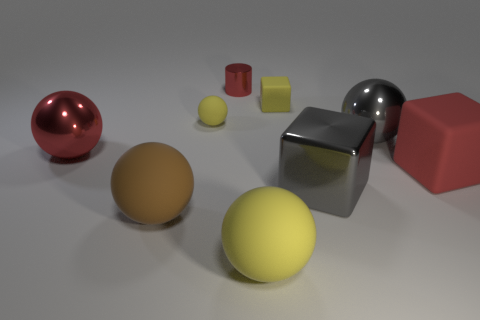Add 1 large gray cubes. How many objects exist? 10 Subtract all yellow balls. How many balls are left? 3 Subtract all large yellow spheres. How many spheres are left? 4 Subtract 1 red spheres. How many objects are left? 8 Subtract all cubes. How many objects are left? 6 Subtract 2 spheres. How many spheres are left? 3 Subtract all green spheres. Subtract all cyan blocks. How many spheres are left? 5 Subtract all blue cylinders. How many brown balls are left? 1 Subtract all large brown balls. Subtract all matte cubes. How many objects are left? 6 Add 5 big brown objects. How many big brown objects are left? 6 